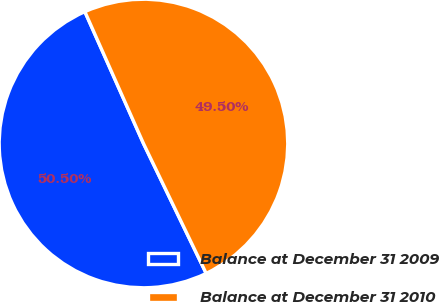Convert chart. <chart><loc_0><loc_0><loc_500><loc_500><pie_chart><fcel>Balance at December 31 2009<fcel>Balance at December 31 2010<nl><fcel>50.5%<fcel>49.5%<nl></chart> 